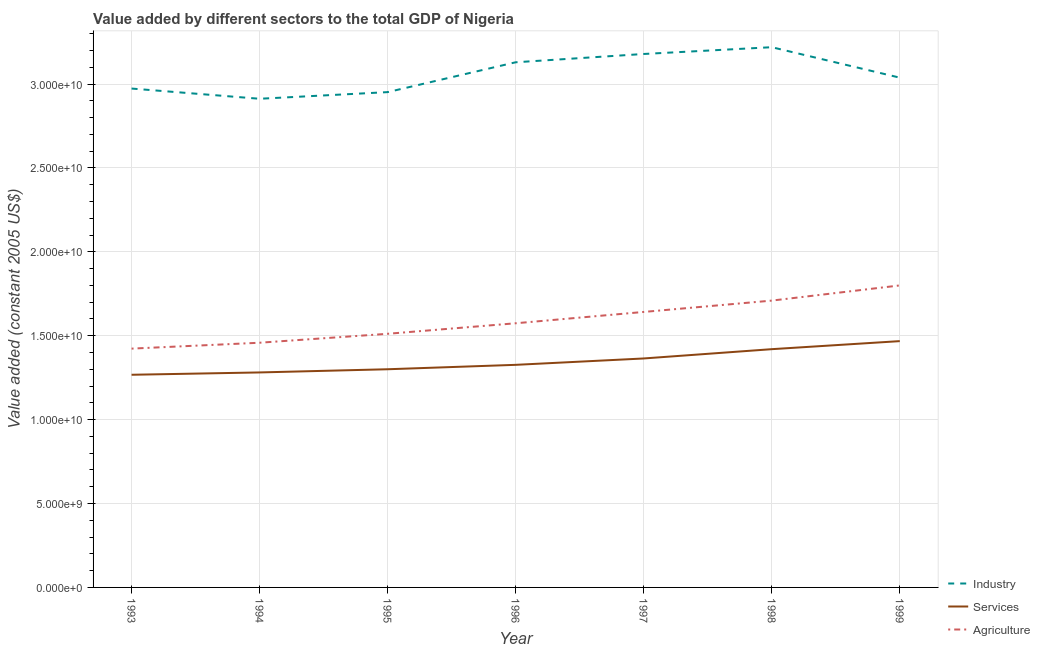How many different coloured lines are there?
Provide a succinct answer. 3. Does the line corresponding to value added by industrial sector intersect with the line corresponding to value added by services?
Provide a succinct answer. No. What is the value added by agricultural sector in 1995?
Provide a succinct answer. 1.51e+1. Across all years, what is the maximum value added by industrial sector?
Offer a very short reply. 3.22e+1. Across all years, what is the minimum value added by industrial sector?
Provide a short and direct response. 2.91e+1. What is the total value added by agricultural sector in the graph?
Your response must be concise. 1.11e+11. What is the difference between the value added by agricultural sector in 1995 and that in 1999?
Offer a very short reply. -2.88e+09. What is the difference between the value added by agricultural sector in 1997 and the value added by industrial sector in 1996?
Give a very brief answer. -1.49e+1. What is the average value added by agricultural sector per year?
Give a very brief answer. 1.59e+1. In the year 1996, what is the difference between the value added by services and value added by industrial sector?
Offer a terse response. -1.80e+1. What is the ratio of the value added by industrial sector in 1997 to that in 1998?
Offer a terse response. 0.99. Is the difference between the value added by services in 1994 and 1998 greater than the difference between the value added by industrial sector in 1994 and 1998?
Provide a short and direct response. Yes. What is the difference between the highest and the second highest value added by agricultural sector?
Make the answer very short. 9.04e+08. What is the difference between the highest and the lowest value added by services?
Keep it short and to the point. 2.00e+09. In how many years, is the value added by agricultural sector greater than the average value added by agricultural sector taken over all years?
Keep it short and to the point. 3. Is the sum of the value added by services in 1997 and 1998 greater than the maximum value added by industrial sector across all years?
Ensure brevity in your answer.  No. Is the value added by industrial sector strictly greater than the value added by agricultural sector over the years?
Keep it short and to the point. Yes. Is the value added by industrial sector strictly less than the value added by services over the years?
Your answer should be compact. No. How many lines are there?
Offer a terse response. 3. Are the values on the major ticks of Y-axis written in scientific E-notation?
Your answer should be compact. Yes. Does the graph contain grids?
Make the answer very short. Yes. Where does the legend appear in the graph?
Offer a terse response. Bottom right. What is the title of the graph?
Provide a succinct answer. Value added by different sectors to the total GDP of Nigeria. Does "Industry" appear as one of the legend labels in the graph?
Your answer should be compact. Yes. What is the label or title of the Y-axis?
Offer a terse response. Value added (constant 2005 US$). What is the Value added (constant 2005 US$) in Industry in 1993?
Your response must be concise. 2.97e+1. What is the Value added (constant 2005 US$) of Services in 1993?
Provide a short and direct response. 1.27e+1. What is the Value added (constant 2005 US$) of Agriculture in 1993?
Your answer should be very brief. 1.42e+1. What is the Value added (constant 2005 US$) of Industry in 1994?
Make the answer very short. 2.91e+1. What is the Value added (constant 2005 US$) in Services in 1994?
Provide a succinct answer. 1.28e+1. What is the Value added (constant 2005 US$) of Agriculture in 1994?
Your answer should be very brief. 1.46e+1. What is the Value added (constant 2005 US$) in Industry in 1995?
Your answer should be compact. 2.95e+1. What is the Value added (constant 2005 US$) in Services in 1995?
Your answer should be very brief. 1.30e+1. What is the Value added (constant 2005 US$) in Agriculture in 1995?
Your answer should be very brief. 1.51e+1. What is the Value added (constant 2005 US$) of Industry in 1996?
Your response must be concise. 3.13e+1. What is the Value added (constant 2005 US$) in Services in 1996?
Offer a very short reply. 1.33e+1. What is the Value added (constant 2005 US$) in Agriculture in 1996?
Ensure brevity in your answer.  1.57e+1. What is the Value added (constant 2005 US$) of Industry in 1997?
Offer a terse response. 3.18e+1. What is the Value added (constant 2005 US$) in Services in 1997?
Your answer should be very brief. 1.36e+1. What is the Value added (constant 2005 US$) of Agriculture in 1997?
Ensure brevity in your answer.  1.64e+1. What is the Value added (constant 2005 US$) of Industry in 1998?
Offer a terse response. 3.22e+1. What is the Value added (constant 2005 US$) of Services in 1998?
Provide a short and direct response. 1.42e+1. What is the Value added (constant 2005 US$) in Agriculture in 1998?
Ensure brevity in your answer.  1.71e+1. What is the Value added (constant 2005 US$) in Industry in 1999?
Your response must be concise. 3.04e+1. What is the Value added (constant 2005 US$) in Services in 1999?
Keep it short and to the point. 1.47e+1. What is the Value added (constant 2005 US$) in Agriculture in 1999?
Your answer should be very brief. 1.80e+1. Across all years, what is the maximum Value added (constant 2005 US$) of Industry?
Offer a terse response. 3.22e+1. Across all years, what is the maximum Value added (constant 2005 US$) in Services?
Your response must be concise. 1.47e+1. Across all years, what is the maximum Value added (constant 2005 US$) in Agriculture?
Keep it short and to the point. 1.80e+1. Across all years, what is the minimum Value added (constant 2005 US$) of Industry?
Provide a succinct answer. 2.91e+1. Across all years, what is the minimum Value added (constant 2005 US$) of Services?
Your response must be concise. 1.27e+1. Across all years, what is the minimum Value added (constant 2005 US$) in Agriculture?
Offer a very short reply. 1.42e+1. What is the total Value added (constant 2005 US$) in Industry in the graph?
Keep it short and to the point. 2.14e+11. What is the total Value added (constant 2005 US$) of Services in the graph?
Your response must be concise. 9.43e+1. What is the total Value added (constant 2005 US$) in Agriculture in the graph?
Give a very brief answer. 1.11e+11. What is the difference between the Value added (constant 2005 US$) in Industry in 1993 and that in 1994?
Your answer should be very brief. 6.09e+08. What is the difference between the Value added (constant 2005 US$) in Services in 1993 and that in 1994?
Keep it short and to the point. -1.39e+08. What is the difference between the Value added (constant 2005 US$) of Agriculture in 1993 and that in 1994?
Keep it short and to the point. -3.51e+08. What is the difference between the Value added (constant 2005 US$) in Industry in 1993 and that in 1995?
Give a very brief answer. 2.13e+08. What is the difference between the Value added (constant 2005 US$) of Services in 1993 and that in 1995?
Your answer should be compact. -3.29e+08. What is the difference between the Value added (constant 2005 US$) of Agriculture in 1993 and that in 1995?
Offer a terse response. -8.83e+08. What is the difference between the Value added (constant 2005 US$) of Industry in 1993 and that in 1996?
Offer a very short reply. -1.57e+09. What is the difference between the Value added (constant 2005 US$) of Services in 1993 and that in 1996?
Your answer should be compact. -5.92e+08. What is the difference between the Value added (constant 2005 US$) in Agriculture in 1993 and that in 1996?
Make the answer very short. -1.51e+09. What is the difference between the Value added (constant 2005 US$) in Industry in 1993 and that in 1997?
Keep it short and to the point. -2.06e+09. What is the difference between the Value added (constant 2005 US$) in Services in 1993 and that in 1997?
Give a very brief answer. -9.72e+08. What is the difference between the Value added (constant 2005 US$) in Agriculture in 1993 and that in 1997?
Provide a succinct answer. -2.19e+09. What is the difference between the Value added (constant 2005 US$) of Industry in 1993 and that in 1998?
Your answer should be compact. -2.46e+09. What is the difference between the Value added (constant 2005 US$) of Services in 1993 and that in 1998?
Keep it short and to the point. -1.53e+09. What is the difference between the Value added (constant 2005 US$) in Agriculture in 1993 and that in 1998?
Your answer should be very brief. -2.86e+09. What is the difference between the Value added (constant 2005 US$) in Industry in 1993 and that in 1999?
Provide a succinct answer. -6.49e+08. What is the difference between the Value added (constant 2005 US$) of Services in 1993 and that in 1999?
Provide a short and direct response. -2.00e+09. What is the difference between the Value added (constant 2005 US$) of Agriculture in 1993 and that in 1999?
Your answer should be very brief. -3.77e+09. What is the difference between the Value added (constant 2005 US$) of Industry in 1994 and that in 1995?
Make the answer very short. -3.96e+08. What is the difference between the Value added (constant 2005 US$) in Services in 1994 and that in 1995?
Provide a short and direct response. -1.90e+08. What is the difference between the Value added (constant 2005 US$) in Agriculture in 1994 and that in 1995?
Offer a terse response. -5.32e+08. What is the difference between the Value added (constant 2005 US$) in Industry in 1994 and that in 1996?
Your response must be concise. -2.17e+09. What is the difference between the Value added (constant 2005 US$) of Services in 1994 and that in 1996?
Give a very brief answer. -4.53e+08. What is the difference between the Value added (constant 2005 US$) of Agriculture in 1994 and that in 1996?
Provide a short and direct response. -1.16e+09. What is the difference between the Value added (constant 2005 US$) of Industry in 1994 and that in 1997?
Offer a terse response. -2.67e+09. What is the difference between the Value added (constant 2005 US$) of Services in 1994 and that in 1997?
Offer a very short reply. -8.33e+08. What is the difference between the Value added (constant 2005 US$) in Agriculture in 1994 and that in 1997?
Give a very brief answer. -1.83e+09. What is the difference between the Value added (constant 2005 US$) of Industry in 1994 and that in 1998?
Your response must be concise. -3.07e+09. What is the difference between the Value added (constant 2005 US$) of Services in 1994 and that in 1998?
Offer a very short reply. -1.39e+09. What is the difference between the Value added (constant 2005 US$) in Agriculture in 1994 and that in 1998?
Make the answer very short. -2.51e+09. What is the difference between the Value added (constant 2005 US$) in Industry in 1994 and that in 1999?
Provide a short and direct response. -1.26e+09. What is the difference between the Value added (constant 2005 US$) in Services in 1994 and that in 1999?
Your answer should be very brief. -1.87e+09. What is the difference between the Value added (constant 2005 US$) of Agriculture in 1994 and that in 1999?
Give a very brief answer. -3.41e+09. What is the difference between the Value added (constant 2005 US$) in Industry in 1995 and that in 1996?
Provide a succinct answer. -1.78e+09. What is the difference between the Value added (constant 2005 US$) in Services in 1995 and that in 1996?
Ensure brevity in your answer.  -2.63e+08. What is the difference between the Value added (constant 2005 US$) in Agriculture in 1995 and that in 1996?
Keep it short and to the point. -6.28e+08. What is the difference between the Value added (constant 2005 US$) of Industry in 1995 and that in 1997?
Your response must be concise. -2.27e+09. What is the difference between the Value added (constant 2005 US$) in Services in 1995 and that in 1997?
Your response must be concise. -6.43e+08. What is the difference between the Value added (constant 2005 US$) in Agriculture in 1995 and that in 1997?
Your response must be concise. -1.30e+09. What is the difference between the Value added (constant 2005 US$) of Industry in 1995 and that in 1998?
Provide a short and direct response. -2.68e+09. What is the difference between the Value added (constant 2005 US$) of Services in 1995 and that in 1998?
Make the answer very short. -1.20e+09. What is the difference between the Value added (constant 2005 US$) of Agriculture in 1995 and that in 1998?
Make the answer very short. -1.98e+09. What is the difference between the Value added (constant 2005 US$) of Industry in 1995 and that in 1999?
Give a very brief answer. -8.62e+08. What is the difference between the Value added (constant 2005 US$) in Services in 1995 and that in 1999?
Make the answer very short. -1.68e+09. What is the difference between the Value added (constant 2005 US$) in Agriculture in 1995 and that in 1999?
Ensure brevity in your answer.  -2.88e+09. What is the difference between the Value added (constant 2005 US$) in Industry in 1996 and that in 1997?
Keep it short and to the point. -4.94e+08. What is the difference between the Value added (constant 2005 US$) of Services in 1996 and that in 1997?
Keep it short and to the point. -3.80e+08. What is the difference between the Value added (constant 2005 US$) of Agriculture in 1996 and that in 1997?
Provide a short and direct response. -6.75e+08. What is the difference between the Value added (constant 2005 US$) of Industry in 1996 and that in 1998?
Your answer should be very brief. -8.98e+08. What is the difference between the Value added (constant 2005 US$) in Services in 1996 and that in 1998?
Keep it short and to the point. -9.34e+08. What is the difference between the Value added (constant 2005 US$) of Agriculture in 1996 and that in 1998?
Your answer should be very brief. -1.35e+09. What is the difference between the Value added (constant 2005 US$) in Industry in 1996 and that in 1999?
Give a very brief answer. 9.17e+08. What is the difference between the Value added (constant 2005 US$) of Services in 1996 and that in 1999?
Give a very brief answer. -1.41e+09. What is the difference between the Value added (constant 2005 US$) of Agriculture in 1996 and that in 1999?
Your response must be concise. -2.25e+09. What is the difference between the Value added (constant 2005 US$) in Industry in 1997 and that in 1998?
Your response must be concise. -4.04e+08. What is the difference between the Value added (constant 2005 US$) in Services in 1997 and that in 1998?
Offer a terse response. -5.54e+08. What is the difference between the Value added (constant 2005 US$) of Agriculture in 1997 and that in 1998?
Ensure brevity in your answer.  -6.75e+08. What is the difference between the Value added (constant 2005 US$) in Industry in 1997 and that in 1999?
Provide a short and direct response. 1.41e+09. What is the difference between the Value added (constant 2005 US$) of Services in 1997 and that in 1999?
Make the answer very short. -1.03e+09. What is the difference between the Value added (constant 2005 US$) of Agriculture in 1997 and that in 1999?
Provide a succinct answer. -1.58e+09. What is the difference between the Value added (constant 2005 US$) in Industry in 1998 and that in 1999?
Offer a very short reply. 1.81e+09. What is the difference between the Value added (constant 2005 US$) in Services in 1998 and that in 1999?
Your answer should be very brief. -4.80e+08. What is the difference between the Value added (constant 2005 US$) of Agriculture in 1998 and that in 1999?
Offer a very short reply. -9.04e+08. What is the difference between the Value added (constant 2005 US$) in Industry in 1993 and the Value added (constant 2005 US$) in Services in 1994?
Your response must be concise. 1.69e+1. What is the difference between the Value added (constant 2005 US$) in Industry in 1993 and the Value added (constant 2005 US$) in Agriculture in 1994?
Keep it short and to the point. 1.51e+1. What is the difference between the Value added (constant 2005 US$) of Services in 1993 and the Value added (constant 2005 US$) of Agriculture in 1994?
Give a very brief answer. -1.91e+09. What is the difference between the Value added (constant 2005 US$) in Industry in 1993 and the Value added (constant 2005 US$) in Services in 1995?
Your answer should be very brief. 1.67e+1. What is the difference between the Value added (constant 2005 US$) of Industry in 1993 and the Value added (constant 2005 US$) of Agriculture in 1995?
Give a very brief answer. 1.46e+1. What is the difference between the Value added (constant 2005 US$) in Services in 1993 and the Value added (constant 2005 US$) in Agriculture in 1995?
Your response must be concise. -2.44e+09. What is the difference between the Value added (constant 2005 US$) in Industry in 1993 and the Value added (constant 2005 US$) in Services in 1996?
Your response must be concise. 1.65e+1. What is the difference between the Value added (constant 2005 US$) of Industry in 1993 and the Value added (constant 2005 US$) of Agriculture in 1996?
Provide a succinct answer. 1.40e+1. What is the difference between the Value added (constant 2005 US$) in Services in 1993 and the Value added (constant 2005 US$) in Agriculture in 1996?
Offer a very short reply. -3.07e+09. What is the difference between the Value added (constant 2005 US$) of Industry in 1993 and the Value added (constant 2005 US$) of Services in 1997?
Ensure brevity in your answer.  1.61e+1. What is the difference between the Value added (constant 2005 US$) of Industry in 1993 and the Value added (constant 2005 US$) of Agriculture in 1997?
Offer a very short reply. 1.33e+1. What is the difference between the Value added (constant 2005 US$) in Services in 1993 and the Value added (constant 2005 US$) in Agriculture in 1997?
Your answer should be very brief. -3.74e+09. What is the difference between the Value added (constant 2005 US$) in Industry in 1993 and the Value added (constant 2005 US$) in Services in 1998?
Ensure brevity in your answer.  1.55e+1. What is the difference between the Value added (constant 2005 US$) of Industry in 1993 and the Value added (constant 2005 US$) of Agriculture in 1998?
Ensure brevity in your answer.  1.26e+1. What is the difference between the Value added (constant 2005 US$) in Services in 1993 and the Value added (constant 2005 US$) in Agriculture in 1998?
Make the answer very short. -4.42e+09. What is the difference between the Value added (constant 2005 US$) of Industry in 1993 and the Value added (constant 2005 US$) of Services in 1999?
Your answer should be compact. 1.51e+1. What is the difference between the Value added (constant 2005 US$) of Industry in 1993 and the Value added (constant 2005 US$) of Agriculture in 1999?
Give a very brief answer. 1.17e+1. What is the difference between the Value added (constant 2005 US$) of Services in 1993 and the Value added (constant 2005 US$) of Agriculture in 1999?
Ensure brevity in your answer.  -5.32e+09. What is the difference between the Value added (constant 2005 US$) of Industry in 1994 and the Value added (constant 2005 US$) of Services in 1995?
Your answer should be compact. 1.61e+1. What is the difference between the Value added (constant 2005 US$) of Industry in 1994 and the Value added (constant 2005 US$) of Agriculture in 1995?
Your response must be concise. 1.40e+1. What is the difference between the Value added (constant 2005 US$) of Services in 1994 and the Value added (constant 2005 US$) of Agriculture in 1995?
Ensure brevity in your answer.  -2.30e+09. What is the difference between the Value added (constant 2005 US$) of Industry in 1994 and the Value added (constant 2005 US$) of Services in 1996?
Keep it short and to the point. 1.59e+1. What is the difference between the Value added (constant 2005 US$) in Industry in 1994 and the Value added (constant 2005 US$) in Agriculture in 1996?
Your answer should be compact. 1.34e+1. What is the difference between the Value added (constant 2005 US$) of Services in 1994 and the Value added (constant 2005 US$) of Agriculture in 1996?
Provide a short and direct response. -2.93e+09. What is the difference between the Value added (constant 2005 US$) of Industry in 1994 and the Value added (constant 2005 US$) of Services in 1997?
Offer a very short reply. 1.55e+1. What is the difference between the Value added (constant 2005 US$) in Industry in 1994 and the Value added (constant 2005 US$) in Agriculture in 1997?
Provide a succinct answer. 1.27e+1. What is the difference between the Value added (constant 2005 US$) of Services in 1994 and the Value added (constant 2005 US$) of Agriculture in 1997?
Keep it short and to the point. -3.61e+09. What is the difference between the Value added (constant 2005 US$) of Industry in 1994 and the Value added (constant 2005 US$) of Services in 1998?
Provide a succinct answer. 1.49e+1. What is the difference between the Value added (constant 2005 US$) in Industry in 1994 and the Value added (constant 2005 US$) in Agriculture in 1998?
Provide a short and direct response. 1.20e+1. What is the difference between the Value added (constant 2005 US$) in Services in 1994 and the Value added (constant 2005 US$) in Agriculture in 1998?
Ensure brevity in your answer.  -4.28e+09. What is the difference between the Value added (constant 2005 US$) of Industry in 1994 and the Value added (constant 2005 US$) of Services in 1999?
Make the answer very short. 1.44e+1. What is the difference between the Value added (constant 2005 US$) of Industry in 1994 and the Value added (constant 2005 US$) of Agriculture in 1999?
Offer a terse response. 1.11e+1. What is the difference between the Value added (constant 2005 US$) of Services in 1994 and the Value added (constant 2005 US$) of Agriculture in 1999?
Make the answer very short. -5.19e+09. What is the difference between the Value added (constant 2005 US$) of Industry in 1995 and the Value added (constant 2005 US$) of Services in 1996?
Keep it short and to the point. 1.63e+1. What is the difference between the Value added (constant 2005 US$) in Industry in 1995 and the Value added (constant 2005 US$) in Agriculture in 1996?
Keep it short and to the point. 1.38e+1. What is the difference between the Value added (constant 2005 US$) in Services in 1995 and the Value added (constant 2005 US$) in Agriculture in 1996?
Offer a terse response. -2.74e+09. What is the difference between the Value added (constant 2005 US$) of Industry in 1995 and the Value added (constant 2005 US$) of Services in 1997?
Your answer should be compact. 1.59e+1. What is the difference between the Value added (constant 2005 US$) in Industry in 1995 and the Value added (constant 2005 US$) in Agriculture in 1997?
Your response must be concise. 1.31e+1. What is the difference between the Value added (constant 2005 US$) of Services in 1995 and the Value added (constant 2005 US$) of Agriculture in 1997?
Offer a terse response. -3.42e+09. What is the difference between the Value added (constant 2005 US$) in Industry in 1995 and the Value added (constant 2005 US$) in Services in 1998?
Offer a very short reply. 1.53e+1. What is the difference between the Value added (constant 2005 US$) in Industry in 1995 and the Value added (constant 2005 US$) in Agriculture in 1998?
Provide a short and direct response. 1.24e+1. What is the difference between the Value added (constant 2005 US$) in Services in 1995 and the Value added (constant 2005 US$) in Agriculture in 1998?
Give a very brief answer. -4.09e+09. What is the difference between the Value added (constant 2005 US$) in Industry in 1995 and the Value added (constant 2005 US$) in Services in 1999?
Provide a short and direct response. 1.48e+1. What is the difference between the Value added (constant 2005 US$) in Industry in 1995 and the Value added (constant 2005 US$) in Agriculture in 1999?
Keep it short and to the point. 1.15e+1. What is the difference between the Value added (constant 2005 US$) of Services in 1995 and the Value added (constant 2005 US$) of Agriculture in 1999?
Your answer should be very brief. -5.00e+09. What is the difference between the Value added (constant 2005 US$) of Industry in 1996 and the Value added (constant 2005 US$) of Services in 1997?
Your response must be concise. 1.77e+1. What is the difference between the Value added (constant 2005 US$) in Industry in 1996 and the Value added (constant 2005 US$) in Agriculture in 1997?
Give a very brief answer. 1.49e+1. What is the difference between the Value added (constant 2005 US$) of Services in 1996 and the Value added (constant 2005 US$) of Agriculture in 1997?
Your response must be concise. -3.15e+09. What is the difference between the Value added (constant 2005 US$) of Industry in 1996 and the Value added (constant 2005 US$) of Services in 1998?
Provide a succinct answer. 1.71e+1. What is the difference between the Value added (constant 2005 US$) in Industry in 1996 and the Value added (constant 2005 US$) in Agriculture in 1998?
Make the answer very short. 1.42e+1. What is the difference between the Value added (constant 2005 US$) in Services in 1996 and the Value added (constant 2005 US$) in Agriculture in 1998?
Keep it short and to the point. -3.83e+09. What is the difference between the Value added (constant 2005 US$) of Industry in 1996 and the Value added (constant 2005 US$) of Services in 1999?
Your response must be concise. 1.66e+1. What is the difference between the Value added (constant 2005 US$) of Industry in 1996 and the Value added (constant 2005 US$) of Agriculture in 1999?
Provide a succinct answer. 1.33e+1. What is the difference between the Value added (constant 2005 US$) of Services in 1996 and the Value added (constant 2005 US$) of Agriculture in 1999?
Keep it short and to the point. -4.73e+09. What is the difference between the Value added (constant 2005 US$) in Industry in 1997 and the Value added (constant 2005 US$) in Services in 1998?
Make the answer very short. 1.76e+1. What is the difference between the Value added (constant 2005 US$) in Industry in 1997 and the Value added (constant 2005 US$) in Agriculture in 1998?
Keep it short and to the point. 1.47e+1. What is the difference between the Value added (constant 2005 US$) of Services in 1997 and the Value added (constant 2005 US$) of Agriculture in 1998?
Offer a terse response. -3.45e+09. What is the difference between the Value added (constant 2005 US$) of Industry in 1997 and the Value added (constant 2005 US$) of Services in 1999?
Your response must be concise. 1.71e+1. What is the difference between the Value added (constant 2005 US$) in Industry in 1997 and the Value added (constant 2005 US$) in Agriculture in 1999?
Your answer should be compact. 1.38e+1. What is the difference between the Value added (constant 2005 US$) in Services in 1997 and the Value added (constant 2005 US$) in Agriculture in 1999?
Offer a terse response. -4.35e+09. What is the difference between the Value added (constant 2005 US$) of Industry in 1998 and the Value added (constant 2005 US$) of Services in 1999?
Provide a succinct answer. 1.75e+1. What is the difference between the Value added (constant 2005 US$) of Industry in 1998 and the Value added (constant 2005 US$) of Agriculture in 1999?
Provide a short and direct response. 1.42e+1. What is the difference between the Value added (constant 2005 US$) of Services in 1998 and the Value added (constant 2005 US$) of Agriculture in 1999?
Offer a very short reply. -3.80e+09. What is the average Value added (constant 2005 US$) in Industry per year?
Offer a very short reply. 3.06e+1. What is the average Value added (constant 2005 US$) of Services per year?
Your answer should be very brief. 1.35e+1. What is the average Value added (constant 2005 US$) of Agriculture per year?
Your response must be concise. 1.59e+1. In the year 1993, what is the difference between the Value added (constant 2005 US$) of Industry and Value added (constant 2005 US$) of Services?
Your response must be concise. 1.71e+1. In the year 1993, what is the difference between the Value added (constant 2005 US$) of Industry and Value added (constant 2005 US$) of Agriculture?
Keep it short and to the point. 1.55e+1. In the year 1993, what is the difference between the Value added (constant 2005 US$) of Services and Value added (constant 2005 US$) of Agriculture?
Your answer should be compact. -1.56e+09. In the year 1994, what is the difference between the Value added (constant 2005 US$) of Industry and Value added (constant 2005 US$) of Services?
Offer a very short reply. 1.63e+1. In the year 1994, what is the difference between the Value added (constant 2005 US$) of Industry and Value added (constant 2005 US$) of Agriculture?
Your answer should be very brief. 1.45e+1. In the year 1994, what is the difference between the Value added (constant 2005 US$) of Services and Value added (constant 2005 US$) of Agriculture?
Provide a succinct answer. -1.77e+09. In the year 1995, what is the difference between the Value added (constant 2005 US$) in Industry and Value added (constant 2005 US$) in Services?
Provide a succinct answer. 1.65e+1. In the year 1995, what is the difference between the Value added (constant 2005 US$) of Industry and Value added (constant 2005 US$) of Agriculture?
Offer a very short reply. 1.44e+1. In the year 1995, what is the difference between the Value added (constant 2005 US$) in Services and Value added (constant 2005 US$) in Agriculture?
Make the answer very short. -2.11e+09. In the year 1996, what is the difference between the Value added (constant 2005 US$) in Industry and Value added (constant 2005 US$) in Services?
Make the answer very short. 1.80e+1. In the year 1996, what is the difference between the Value added (constant 2005 US$) in Industry and Value added (constant 2005 US$) in Agriculture?
Provide a succinct answer. 1.56e+1. In the year 1996, what is the difference between the Value added (constant 2005 US$) in Services and Value added (constant 2005 US$) in Agriculture?
Keep it short and to the point. -2.48e+09. In the year 1997, what is the difference between the Value added (constant 2005 US$) of Industry and Value added (constant 2005 US$) of Services?
Your response must be concise. 1.81e+1. In the year 1997, what is the difference between the Value added (constant 2005 US$) of Industry and Value added (constant 2005 US$) of Agriculture?
Offer a very short reply. 1.54e+1. In the year 1997, what is the difference between the Value added (constant 2005 US$) in Services and Value added (constant 2005 US$) in Agriculture?
Offer a very short reply. -2.77e+09. In the year 1998, what is the difference between the Value added (constant 2005 US$) in Industry and Value added (constant 2005 US$) in Services?
Make the answer very short. 1.80e+1. In the year 1998, what is the difference between the Value added (constant 2005 US$) of Industry and Value added (constant 2005 US$) of Agriculture?
Provide a succinct answer. 1.51e+1. In the year 1998, what is the difference between the Value added (constant 2005 US$) of Services and Value added (constant 2005 US$) of Agriculture?
Ensure brevity in your answer.  -2.89e+09. In the year 1999, what is the difference between the Value added (constant 2005 US$) in Industry and Value added (constant 2005 US$) in Services?
Ensure brevity in your answer.  1.57e+1. In the year 1999, what is the difference between the Value added (constant 2005 US$) in Industry and Value added (constant 2005 US$) in Agriculture?
Your response must be concise. 1.24e+1. In the year 1999, what is the difference between the Value added (constant 2005 US$) in Services and Value added (constant 2005 US$) in Agriculture?
Your answer should be very brief. -3.32e+09. What is the ratio of the Value added (constant 2005 US$) in Industry in 1993 to that in 1994?
Your answer should be compact. 1.02. What is the ratio of the Value added (constant 2005 US$) in Services in 1993 to that in 1994?
Provide a succinct answer. 0.99. What is the ratio of the Value added (constant 2005 US$) of Agriculture in 1993 to that in 1994?
Keep it short and to the point. 0.98. What is the ratio of the Value added (constant 2005 US$) in Industry in 1993 to that in 1995?
Provide a short and direct response. 1.01. What is the ratio of the Value added (constant 2005 US$) in Services in 1993 to that in 1995?
Your answer should be compact. 0.97. What is the ratio of the Value added (constant 2005 US$) in Agriculture in 1993 to that in 1995?
Your response must be concise. 0.94. What is the ratio of the Value added (constant 2005 US$) in Industry in 1993 to that in 1996?
Offer a very short reply. 0.95. What is the ratio of the Value added (constant 2005 US$) in Services in 1993 to that in 1996?
Give a very brief answer. 0.96. What is the ratio of the Value added (constant 2005 US$) in Agriculture in 1993 to that in 1996?
Your response must be concise. 0.9. What is the ratio of the Value added (constant 2005 US$) of Industry in 1993 to that in 1997?
Provide a succinct answer. 0.94. What is the ratio of the Value added (constant 2005 US$) in Services in 1993 to that in 1997?
Give a very brief answer. 0.93. What is the ratio of the Value added (constant 2005 US$) in Agriculture in 1993 to that in 1997?
Offer a very short reply. 0.87. What is the ratio of the Value added (constant 2005 US$) in Industry in 1993 to that in 1998?
Provide a succinct answer. 0.92. What is the ratio of the Value added (constant 2005 US$) in Services in 1993 to that in 1998?
Keep it short and to the point. 0.89. What is the ratio of the Value added (constant 2005 US$) in Agriculture in 1993 to that in 1998?
Provide a short and direct response. 0.83. What is the ratio of the Value added (constant 2005 US$) of Industry in 1993 to that in 1999?
Keep it short and to the point. 0.98. What is the ratio of the Value added (constant 2005 US$) in Services in 1993 to that in 1999?
Provide a succinct answer. 0.86. What is the ratio of the Value added (constant 2005 US$) in Agriculture in 1993 to that in 1999?
Give a very brief answer. 0.79. What is the ratio of the Value added (constant 2005 US$) of Industry in 1994 to that in 1995?
Make the answer very short. 0.99. What is the ratio of the Value added (constant 2005 US$) in Services in 1994 to that in 1995?
Your response must be concise. 0.99. What is the ratio of the Value added (constant 2005 US$) of Agriculture in 1994 to that in 1995?
Your response must be concise. 0.96. What is the ratio of the Value added (constant 2005 US$) of Industry in 1994 to that in 1996?
Keep it short and to the point. 0.93. What is the ratio of the Value added (constant 2005 US$) in Services in 1994 to that in 1996?
Offer a terse response. 0.97. What is the ratio of the Value added (constant 2005 US$) of Agriculture in 1994 to that in 1996?
Provide a short and direct response. 0.93. What is the ratio of the Value added (constant 2005 US$) in Industry in 1994 to that in 1997?
Provide a short and direct response. 0.92. What is the ratio of the Value added (constant 2005 US$) of Services in 1994 to that in 1997?
Give a very brief answer. 0.94. What is the ratio of the Value added (constant 2005 US$) in Agriculture in 1994 to that in 1997?
Keep it short and to the point. 0.89. What is the ratio of the Value added (constant 2005 US$) of Industry in 1994 to that in 1998?
Offer a terse response. 0.9. What is the ratio of the Value added (constant 2005 US$) of Services in 1994 to that in 1998?
Offer a terse response. 0.9. What is the ratio of the Value added (constant 2005 US$) of Agriculture in 1994 to that in 1998?
Your response must be concise. 0.85. What is the ratio of the Value added (constant 2005 US$) in Industry in 1994 to that in 1999?
Keep it short and to the point. 0.96. What is the ratio of the Value added (constant 2005 US$) of Services in 1994 to that in 1999?
Your answer should be very brief. 0.87. What is the ratio of the Value added (constant 2005 US$) of Agriculture in 1994 to that in 1999?
Your answer should be very brief. 0.81. What is the ratio of the Value added (constant 2005 US$) in Industry in 1995 to that in 1996?
Give a very brief answer. 0.94. What is the ratio of the Value added (constant 2005 US$) in Services in 1995 to that in 1996?
Give a very brief answer. 0.98. What is the ratio of the Value added (constant 2005 US$) in Agriculture in 1995 to that in 1996?
Provide a short and direct response. 0.96. What is the ratio of the Value added (constant 2005 US$) in Industry in 1995 to that in 1997?
Make the answer very short. 0.93. What is the ratio of the Value added (constant 2005 US$) of Services in 1995 to that in 1997?
Ensure brevity in your answer.  0.95. What is the ratio of the Value added (constant 2005 US$) in Agriculture in 1995 to that in 1997?
Offer a terse response. 0.92. What is the ratio of the Value added (constant 2005 US$) in Industry in 1995 to that in 1998?
Your answer should be compact. 0.92. What is the ratio of the Value added (constant 2005 US$) of Services in 1995 to that in 1998?
Offer a very short reply. 0.92. What is the ratio of the Value added (constant 2005 US$) in Agriculture in 1995 to that in 1998?
Provide a succinct answer. 0.88. What is the ratio of the Value added (constant 2005 US$) of Industry in 1995 to that in 1999?
Provide a short and direct response. 0.97. What is the ratio of the Value added (constant 2005 US$) of Services in 1995 to that in 1999?
Offer a terse response. 0.89. What is the ratio of the Value added (constant 2005 US$) in Agriculture in 1995 to that in 1999?
Provide a short and direct response. 0.84. What is the ratio of the Value added (constant 2005 US$) in Industry in 1996 to that in 1997?
Your answer should be very brief. 0.98. What is the ratio of the Value added (constant 2005 US$) of Services in 1996 to that in 1997?
Your response must be concise. 0.97. What is the ratio of the Value added (constant 2005 US$) in Agriculture in 1996 to that in 1997?
Offer a very short reply. 0.96. What is the ratio of the Value added (constant 2005 US$) of Industry in 1996 to that in 1998?
Ensure brevity in your answer.  0.97. What is the ratio of the Value added (constant 2005 US$) of Services in 1996 to that in 1998?
Ensure brevity in your answer.  0.93. What is the ratio of the Value added (constant 2005 US$) of Agriculture in 1996 to that in 1998?
Provide a short and direct response. 0.92. What is the ratio of the Value added (constant 2005 US$) of Industry in 1996 to that in 1999?
Your response must be concise. 1.03. What is the ratio of the Value added (constant 2005 US$) in Services in 1996 to that in 1999?
Offer a terse response. 0.9. What is the ratio of the Value added (constant 2005 US$) in Agriculture in 1996 to that in 1999?
Your response must be concise. 0.87. What is the ratio of the Value added (constant 2005 US$) of Industry in 1997 to that in 1998?
Give a very brief answer. 0.99. What is the ratio of the Value added (constant 2005 US$) of Services in 1997 to that in 1998?
Make the answer very short. 0.96. What is the ratio of the Value added (constant 2005 US$) in Agriculture in 1997 to that in 1998?
Keep it short and to the point. 0.96. What is the ratio of the Value added (constant 2005 US$) of Industry in 1997 to that in 1999?
Your answer should be very brief. 1.05. What is the ratio of the Value added (constant 2005 US$) of Services in 1997 to that in 1999?
Your answer should be compact. 0.93. What is the ratio of the Value added (constant 2005 US$) in Agriculture in 1997 to that in 1999?
Your answer should be compact. 0.91. What is the ratio of the Value added (constant 2005 US$) in Industry in 1998 to that in 1999?
Offer a very short reply. 1.06. What is the ratio of the Value added (constant 2005 US$) of Services in 1998 to that in 1999?
Ensure brevity in your answer.  0.97. What is the ratio of the Value added (constant 2005 US$) in Agriculture in 1998 to that in 1999?
Give a very brief answer. 0.95. What is the difference between the highest and the second highest Value added (constant 2005 US$) of Industry?
Provide a succinct answer. 4.04e+08. What is the difference between the highest and the second highest Value added (constant 2005 US$) of Services?
Ensure brevity in your answer.  4.80e+08. What is the difference between the highest and the second highest Value added (constant 2005 US$) of Agriculture?
Your answer should be compact. 9.04e+08. What is the difference between the highest and the lowest Value added (constant 2005 US$) in Industry?
Offer a terse response. 3.07e+09. What is the difference between the highest and the lowest Value added (constant 2005 US$) of Services?
Your response must be concise. 2.00e+09. What is the difference between the highest and the lowest Value added (constant 2005 US$) of Agriculture?
Make the answer very short. 3.77e+09. 